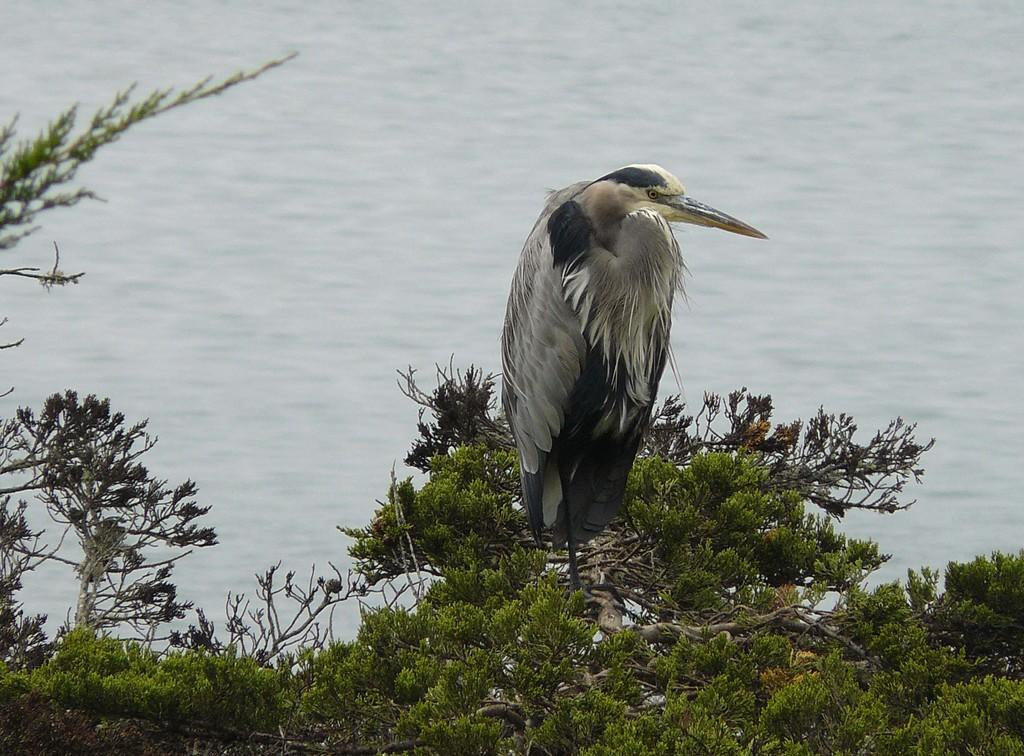What type of animal can be seen in the image? There is a bird in the image. Where is the bird located? The bird is on a tree. What can be seen behind the bird? There is water visible behind the bird. What type of spot does the bird have on its back in the image? There is no mention of a spot on the bird's back in the image. 